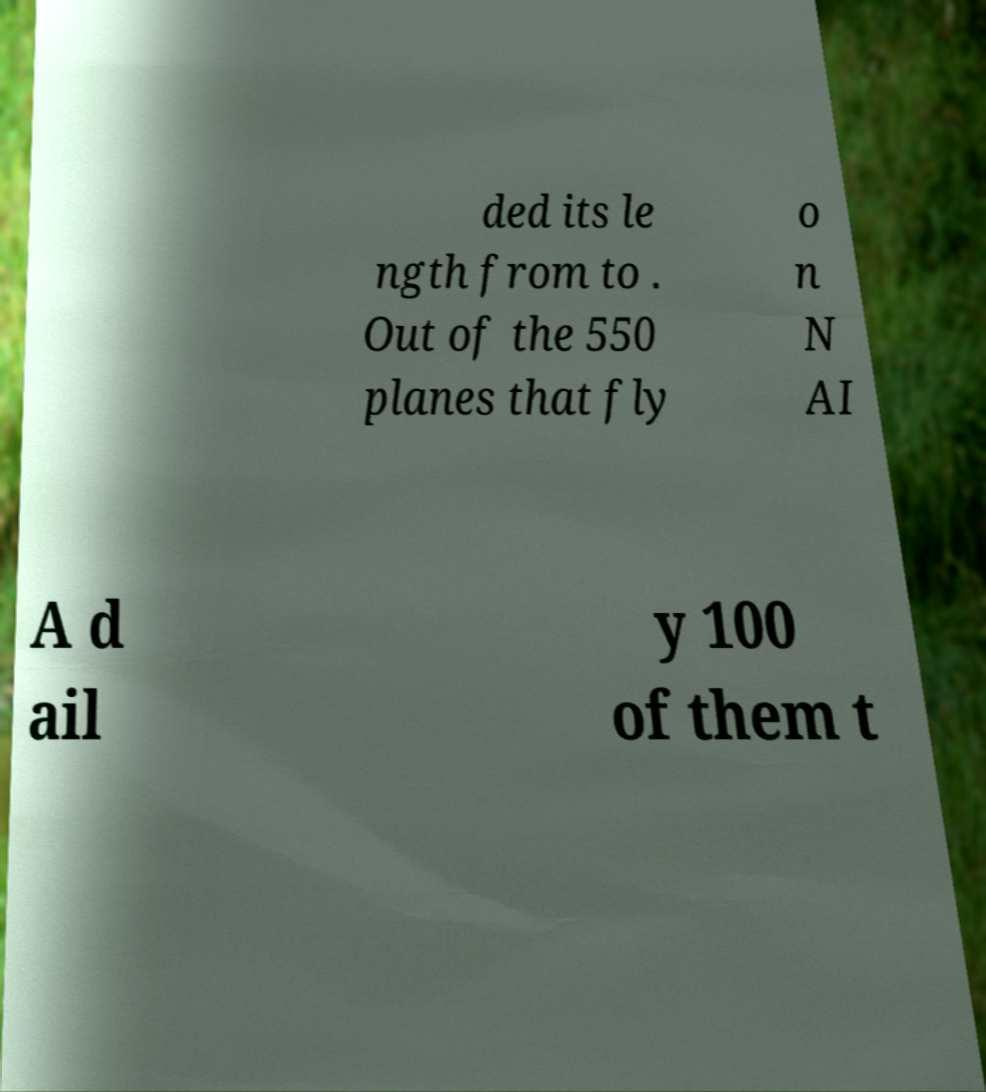Could you extract and type out the text from this image? ded its le ngth from to . Out of the 550 planes that fly o n N AI A d ail y 100 of them t 